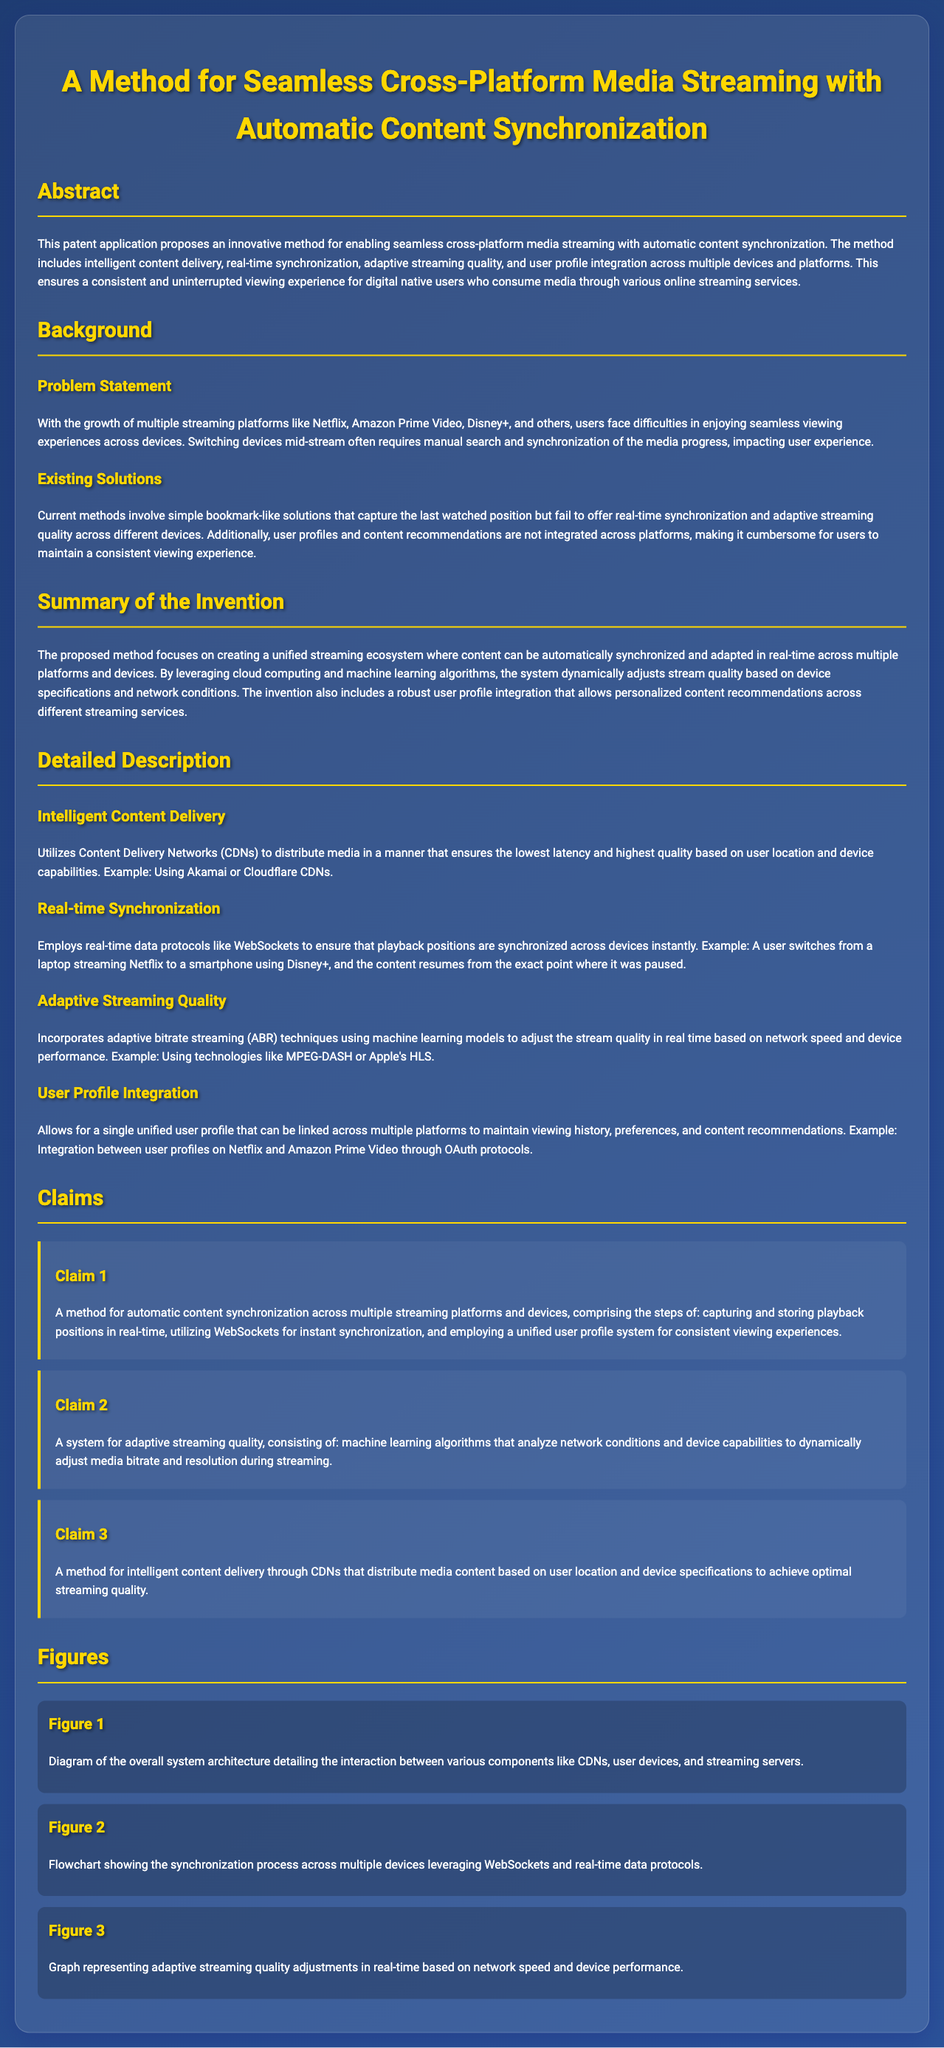what is the title of the patent application? The title is the main heading at the top of the document, describing the main focus of the patent.
Answer: A Method for Seamless Cross-Platform Media Streaming with Automatic Content Synchronization what problem does this invention aim to solve? The problem is stated in the Problem Statement section, detailing the challenges faced by users when switching devices.
Answer: Seamless viewing experiences across devices what technology is used for real-time synchronization? The specific technology mentioned in the Real-time Synchronization section is relevant to ensuring synchronization across devices.
Answer: WebSockets how many claims are listed in the patent application? The number of claims can be counted in the Claims section of the document.
Answer: Three which streaming technologies are mentioned for adaptive streaming quality? The relevant technologies for adjusting stream quality in real-time are these standard methods listed in the Adaptive Streaming Quality section.
Answer: MPEG-DASH or Apple's HLS what is the primary method of intelligent content delivery? The method mentioned in the Intelligent Content Delivery section is explained as a way to deliver media content efficiently.
Answer: Content Delivery Networks how does the unified user profile system benefit users? The Document Summary highlights benefits of a unified user profile regarding viewing history and preferences.
Answer: Consistent viewing experiences what is the purpose of machine learning algorithms in this patent? The purpose is described in the context of adaptive streaming quality and analyzing conditions for performance.
Answer: Adjust media bitrate and resolution what do figures in the document depict? The figures are used to illustrate different processes and systems in the patent, enhancing understanding of the technology.
Answer: System architecture and processes 